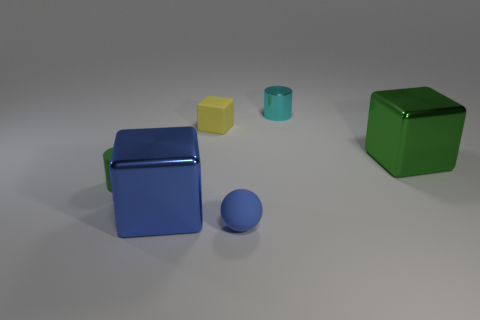Add 2 big red rubber cylinders. How many objects exist? 8 Subtract all spheres. How many objects are left? 5 Add 2 green metal blocks. How many green metal blocks exist? 3 Subtract 1 cyan cylinders. How many objects are left? 5 Subtract all cyan metal cylinders. Subtract all tiny green rubber cylinders. How many objects are left? 4 Add 6 green matte objects. How many green matte objects are left? 7 